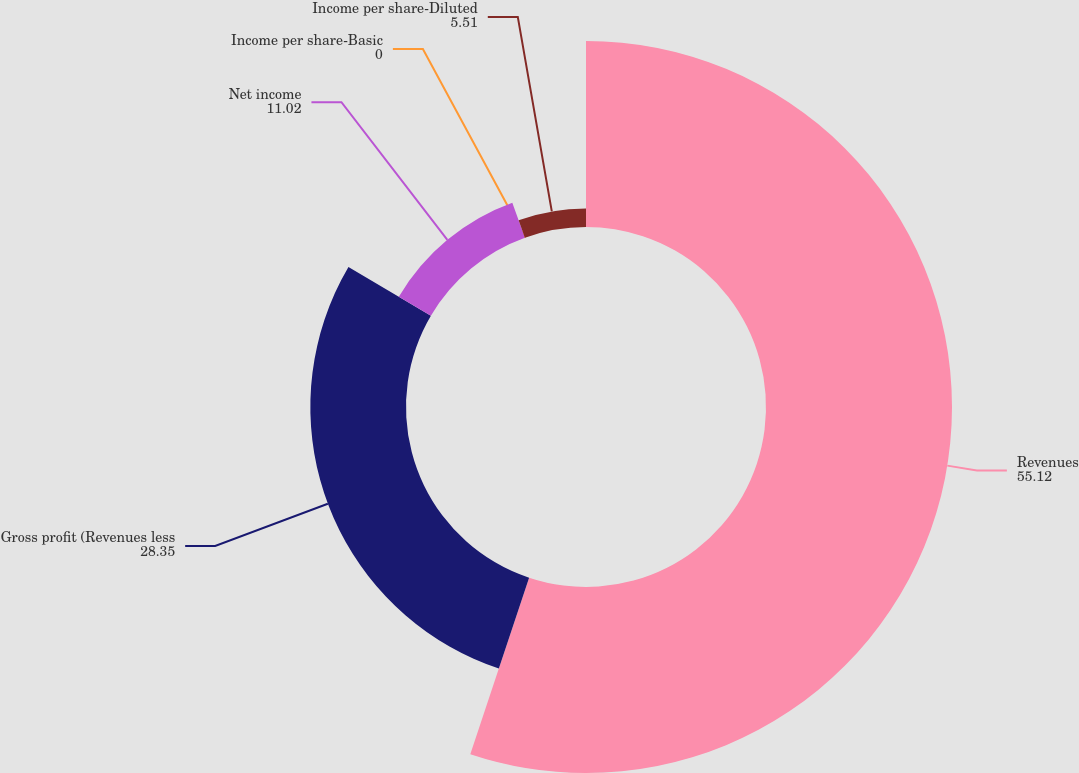Convert chart to OTSL. <chart><loc_0><loc_0><loc_500><loc_500><pie_chart><fcel>Revenues<fcel>Gross profit (Revenues less<fcel>Net income<fcel>Income per share-Basic<fcel>Income per share-Diluted<nl><fcel>55.12%<fcel>28.35%<fcel>11.02%<fcel>0.0%<fcel>5.51%<nl></chart> 